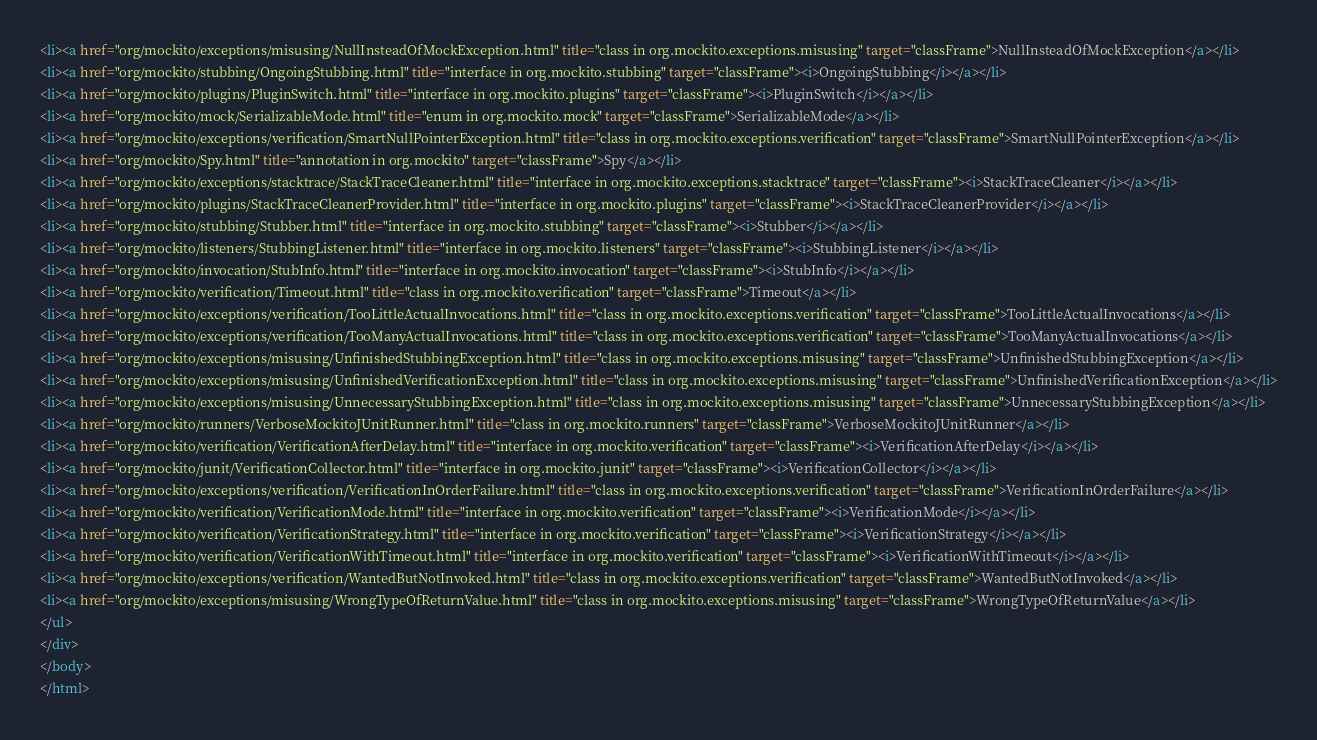Convert code to text. <code><loc_0><loc_0><loc_500><loc_500><_HTML_><li><a href="org/mockito/exceptions/misusing/NullInsteadOfMockException.html" title="class in org.mockito.exceptions.misusing" target="classFrame">NullInsteadOfMockException</a></li>
<li><a href="org/mockito/stubbing/OngoingStubbing.html" title="interface in org.mockito.stubbing" target="classFrame"><i>OngoingStubbing</i></a></li>
<li><a href="org/mockito/plugins/PluginSwitch.html" title="interface in org.mockito.plugins" target="classFrame"><i>PluginSwitch</i></a></li>
<li><a href="org/mockito/mock/SerializableMode.html" title="enum in org.mockito.mock" target="classFrame">SerializableMode</a></li>
<li><a href="org/mockito/exceptions/verification/SmartNullPointerException.html" title="class in org.mockito.exceptions.verification" target="classFrame">SmartNullPointerException</a></li>
<li><a href="org/mockito/Spy.html" title="annotation in org.mockito" target="classFrame">Spy</a></li>
<li><a href="org/mockito/exceptions/stacktrace/StackTraceCleaner.html" title="interface in org.mockito.exceptions.stacktrace" target="classFrame"><i>StackTraceCleaner</i></a></li>
<li><a href="org/mockito/plugins/StackTraceCleanerProvider.html" title="interface in org.mockito.plugins" target="classFrame"><i>StackTraceCleanerProvider</i></a></li>
<li><a href="org/mockito/stubbing/Stubber.html" title="interface in org.mockito.stubbing" target="classFrame"><i>Stubber</i></a></li>
<li><a href="org/mockito/listeners/StubbingListener.html" title="interface in org.mockito.listeners" target="classFrame"><i>StubbingListener</i></a></li>
<li><a href="org/mockito/invocation/StubInfo.html" title="interface in org.mockito.invocation" target="classFrame"><i>StubInfo</i></a></li>
<li><a href="org/mockito/verification/Timeout.html" title="class in org.mockito.verification" target="classFrame">Timeout</a></li>
<li><a href="org/mockito/exceptions/verification/TooLittleActualInvocations.html" title="class in org.mockito.exceptions.verification" target="classFrame">TooLittleActualInvocations</a></li>
<li><a href="org/mockito/exceptions/verification/TooManyActualInvocations.html" title="class in org.mockito.exceptions.verification" target="classFrame">TooManyActualInvocations</a></li>
<li><a href="org/mockito/exceptions/misusing/UnfinishedStubbingException.html" title="class in org.mockito.exceptions.misusing" target="classFrame">UnfinishedStubbingException</a></li>
<li><a href="org/mockito/exceptions/misusing/UnfinishedVerificationException.html" title="class in org.mockito.exceptions.misusing" target="classFrame">UnfinishedVerificationException</a></li>
<li><a href="org/mockito/exceptions/misusing/UnnecessaryStubbingException.html" title="class in org.mockito.exceptions.misusing" target="classFrame">UnnecessaryStubbingException</a></li>
<li><a href="org/mockito/runners/VerboseMockitoJUnitRunner.html" title="class in org.mockito.runners" target="classFrame">VerboseMockitoJUnitRunner</a></li>
<li><a href="org/mockito/verification/VerificationAfterDelay.html" title="interface in org.mockito.verification" target="classFrame"><i>VerificationAfterDelay</i></a></li>
<li><a href="org/mockito/junit/VerificationCollector.html" title="interface in org.mockito.junit" target="classFrame"><i>VerificationCollector</i></a></li>
<li><a href="org/mockito/exceptions/verification/VerificationInOrderFailure.html" title="class in org.mockito.exceptions.verification" target="classFrame">VerificationInOrderFailure</a></li>
<li><a href="org/mockito/verification/VerificationMode.html" title="interface in org.mockito.verification" target="classFrame"><i>VerificationMode</i></a></li>
<li><a href="org/mockito/verification/VerificationStrategy.html" title="interface in org.mockito.verification" target="classFrame"><i>VerificationStrategy</i></a></li>
<li><a href="org/mockito/verification/VerificationWithTimeout.html" title="interface in org.mockito.verification" target="classFrame"><i>VerificationWithTimeout</i></a></li>
<li><a href="org/mockito/exceptions/verification/WantedButNotInvoked.html" title="class in org.mockito.exceptions.verification" target="classFrame">WantedButNotInvoked</a></li>
<li><a href="org/mockito/exceptions/misusing/WrongTypeOfReturnValue.html" title="class in org.mockito.exceptions.misusing" target="classFrame">WrongTypeOfReturnValue</a></li>
</ul>
</div>
</body>
</html>
</code> 